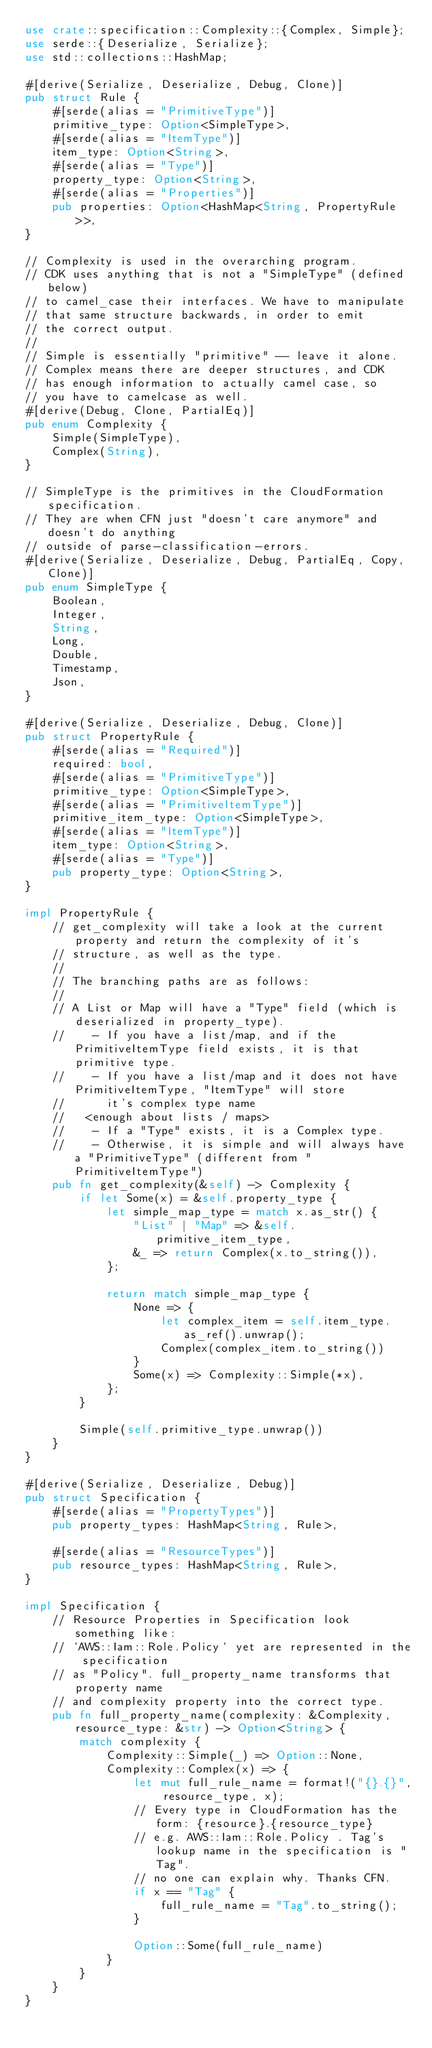Convert code to text. <code><loc_0><loc_0><loc_500><loc_500><_Rust_>use crate::specification::Complexity::{Complex, Simple};
use serde::{Deserialize, Serialize};
use std::collections::HashMap;

#[derive(Serialize, Deserialize, Debug, Clone)]
pub struct Rule {
    #[serde(alias = "PrimitiveType")]
    primitive_type: Option<SimpleType>,
    #[serde(alias = "ItemType")]
    item_type: Option<String>,
    #[serde(alias = "Type")]
    property_type: Option<String>,
    #[serde(alias = "Properties")]
    pub properties: Option<HashMap<String, PropertyRule>>,
}

// Complexity is used in the overarching program.
// CDK uses anything that is not a "SimpleType" (defined below)
// to camel_case their interfaces. We have to manipulate
// that same structure backwards, in order to emit
// the correct output.
//
// Simple is essentially "primitive" -- leave it alone.
// Complex means there are deeper structures, and CDK
// has enough information to actually camel case, so
// you have to camelcase as well.
#[derive(Debug, Clone, PartialEq)]
pub enum Complexity {
    Simple(SimpleType),
    Complex(String),
}

// SimpleType is the primitives in the CloudFormation specification.
// They are when CFN just "doesn't care anymore" and doesn't do anything
// outside of parse-classification-errors.
#[derive(Serialize, Deserialize, Debug, PartialEq, Copy, Clone)]
pub enum SimpleType {
    Boolean,
    Integer,
    String,
    Long,
    Double,
    Timestamp,
    Json,
}

#[derive(Serialize, Deserialize, Debug, Clone)]
pub struct PropertyRule {
    #[serde(alias = "Required")]
    required: bool,
    #[serde(alias = "PrimitiveType")]
    primitive_type: Option<SimpleType>,
    #[serde(alias = "PrimitiveItemType")]
    primitive_item_type: Option<SimpleType>,
    #[serde(alias = "ItemType")]
    item_type: Option<String>,
    #[serde(alias = "Type")]
    pub property_type: Option<String>,
}

impl PropertyRule {
    // get_complexity will take a look at the current property and return the complexity of it's
    // structure, as well as the type.
    //
    // The branching paths are as follows:
    //
    // A List or Map will have a "Type" field (which is deserialized in property_type).
    //    - If you have a list/map, and if the PrimitiveItemType field exists, it is that primitive type.
    //    - If you have a list/map and it does not have PrimitiveItemType, "ItemType" will store
    //      it's complex type name
    //   <enough about lists / maps>
    //    - If a "Type" exists, it is a Complex type.
    //    - Otherwise, it is simple and will always have a "PrimitiveType" (different from "PrimitiveItemType")
    pub fn get_complexity(&self) -> Complexity {
        if let Some(x) = &self.property_type {
            let simple_map_type = match x.as_str() {
                "List" | "Map" => &self.primitive_item_type,
                &_ => return Complex(x.to_string()),
            };

            return match simple_map_type {
                None => {
                    let complex_item = self.item_type.as_ref().unwrap();
                    Complex(complex_item.to_string())
                }
                Some(x) => Complexity::Simple(*x),
            };
        }

        Simple(self.primitive_type.unwrap())
    }
}

#[derive(Serialize, Deserialize, Debug)]
pub struct Specification {
    #[serde(alias = "PropertyTypes")]
    pub property_types: HashMap<String, Rule>,

    #[serde(alias = "ResourceTypes")]
    pub resource_types: HashMap<String, Rule>,
}

impl Specification {
    // Resource Properties in Specification look something like:
    // `AWS::Iam::Role.Policy` yet are represented in the specification
    // as "Policy". full_property_name transforms that property name
    // and complexity property into the correct type.
    pub fn full_property_name(complexity: &Complexity, resource_type: &str) -> Option<String> {
        match complexity {
            Complexity::Simple(_) => Option::None,
            Complexity::Complex(x) => {
                let mut full_rule_name = format!("{}.{}", resource_type, x);
                // Every type in CloudFormation has the form: {resource}.{resource_type}
                // e.g. AWS::Iam::Role.Policy . Tag's lookup name in the specification is "Tag".
                // no one can explain why. Thanks CFN.
                if x == "Tag" {
                    full_rule_name = "Tag".to_string();
                }

                Option::Some(full_rule_name)
            }
        }
    }
}
</code> 